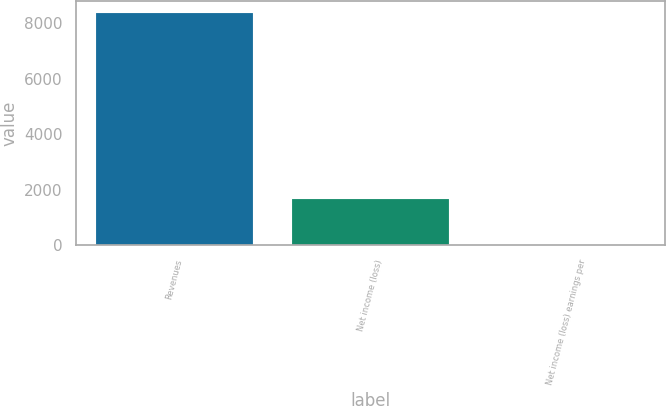<chart> <loc_0><loc_0><loc_500><loc_500><bar_chart><fcel>Revenues<fcel>Net income (loss)<fcel>Net income (loss) earnings per<nl><fcel>8362<fcel>1673.63<fcel>1.53<nl></chart> 